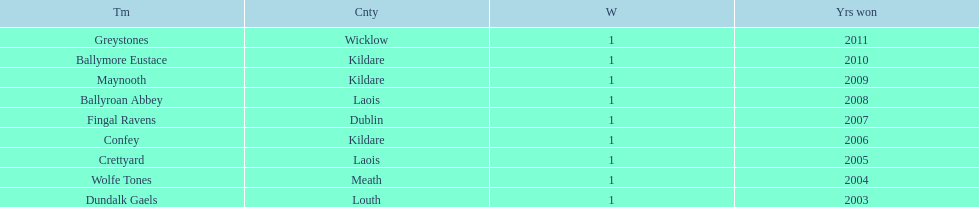What is the number of wins for each team 1. 